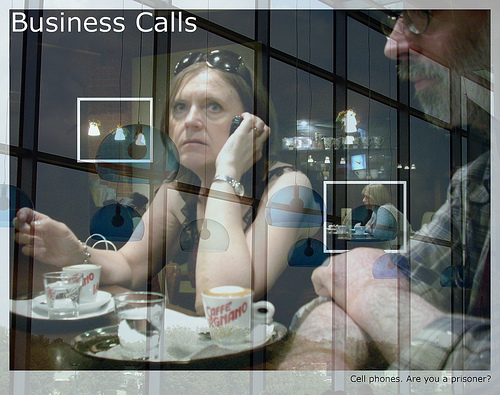Is the woman that is to the left of the cup talking on a phone? Yes, the woman to the left of the coffee cup is talking on a phone. 